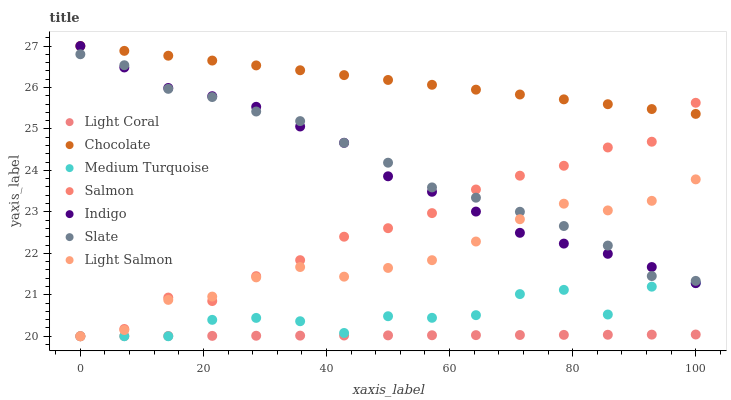Does Light Coral have the minimum area under the curve?
Answer yes or no. Yes. Does Chocolate have the maximum area under the curve?
Answer yes or no. Yes. Does Indigo have the minimum area under the curve?
Answer yes or no. No. Does Indigo have the maximum area under the curve?
Answer yes or no. No. Is Light Coral the smoothest?
Answer yes or no. Yes. Is Medium Turquoise the roughest?
Answer yes or no. Yes. Is Indigo the smoothest?
Answer yes or no. No. Is Indigo the roughest?
Answer yes or no. No. Does Light Salmon have the lowest value?
Answer yes or no. Yes. Does Indigo have the lowest value?
Answer yes or no. No. Does Chocolate have the highest value?
Answer yes or no. Yes. Does Slate have the highest value?
Answer yes or no. No. Is Light Coral less than Chocolate?
Answer yes or no. Yes. Is Chocolate greater than Slate?
Answer yes or no. Yes. Does Salmon intersect Light Coral?
Answer yes or no. Yes. Is Salmon less than Light Coral?
Answer yes or no. No. Is Salmon greater than Light Coral?
Answer yes or no. No. Does Light Coral intersect Chocolate?
Answer yes or no. No. 